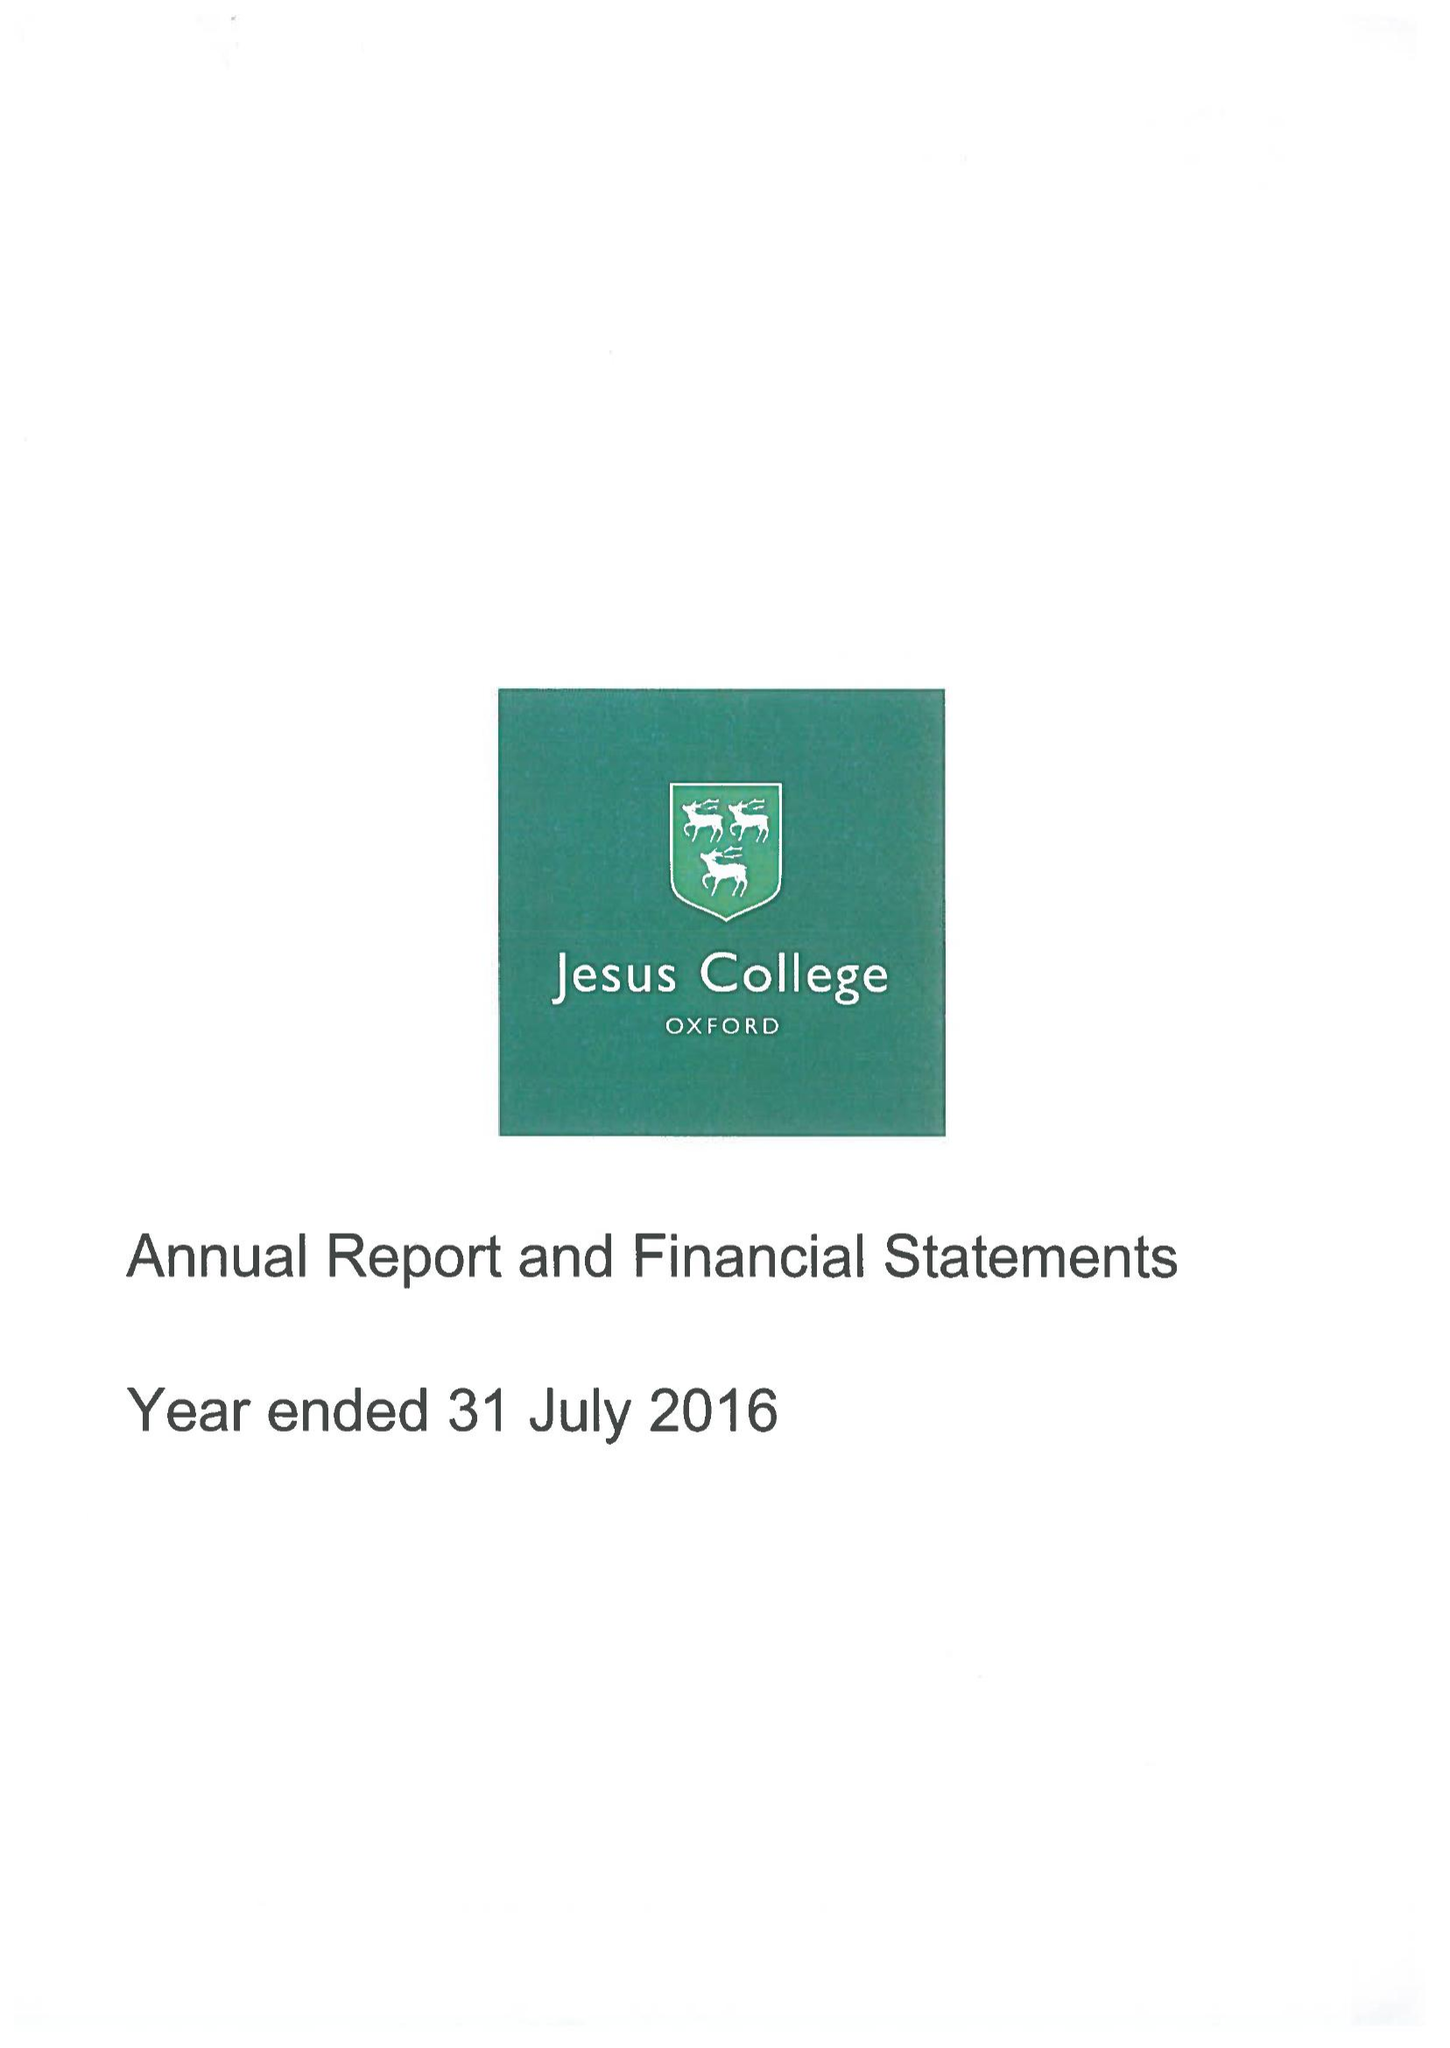What is the value for the charity_name?
Answer the question using a single word or phrase. Jesus College Within The University and City Of Oxford Of Queen Elizabeth's Foundation 